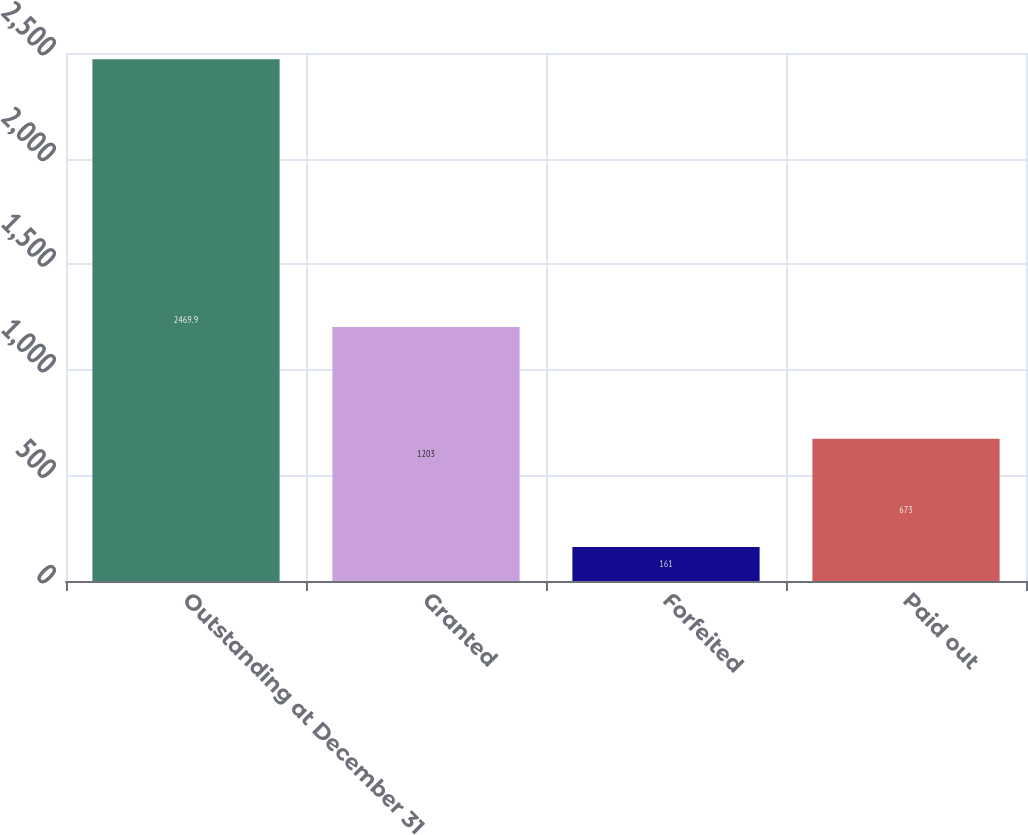Convert chart to OTSL. <chart><loc_0><loc_0><loc_500><loc_500><bar_chart><fcel>Outstanding at December 31<fcel>Granted<fcel>Forfeited<fcel>Paid out<nl><fcel>2469.9<fcel>1203<fcel>161<fcel>673<nl></chart> 